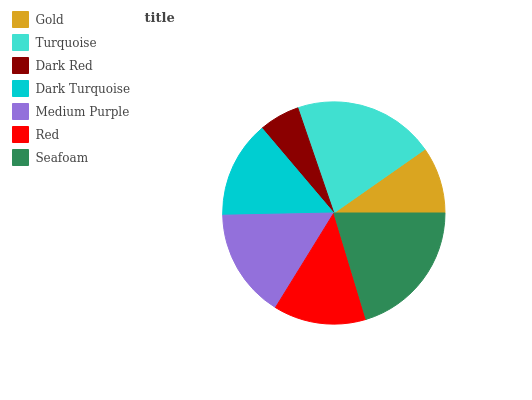Is Dark Red the minimum?
Answer yes or no. Yes. Is Turquoise the maximum?
Answer yes or no. Yes. Is Turquoise the minimum?
Answer yes or no. No. Is Dark Red the maximum?
Answer yes or no. No. Is Turquoise greater than Dark Red?
Answer yes or no. Yes. Is Dark Red less than Turquoise?
Answer yes or no. Yes. Is Dark Red greater than Turquoise?
Answer yes or no. No. Is Turquoise less than Dark Red?
Answer yes or no. No. Is Dark Turquoise the high median?
Answer yes or no. Yes. Is Dark Turquoise the low median?
Answer yes or no. Yes. Is Red the high median?
Answer yes or no. No. Is Gold the low median?
Answer yes or no. No. 